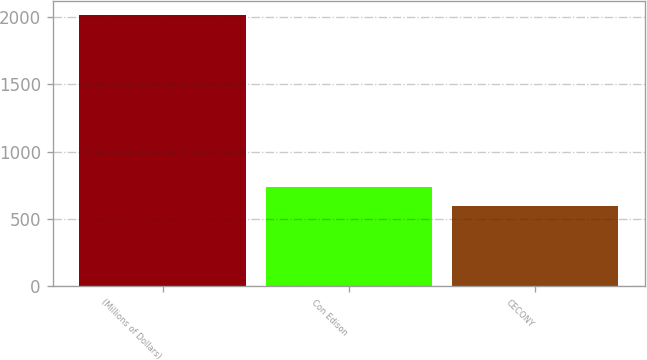<chart> <loc_0><loc_0><loc_500><loc_500><bar_chart><fcel>(Millions of Dollars)<fcel>Con Edison<fcel>CECONY<nl><fcel>2017<fcel>735.4<fcel>593<nl></chart> 